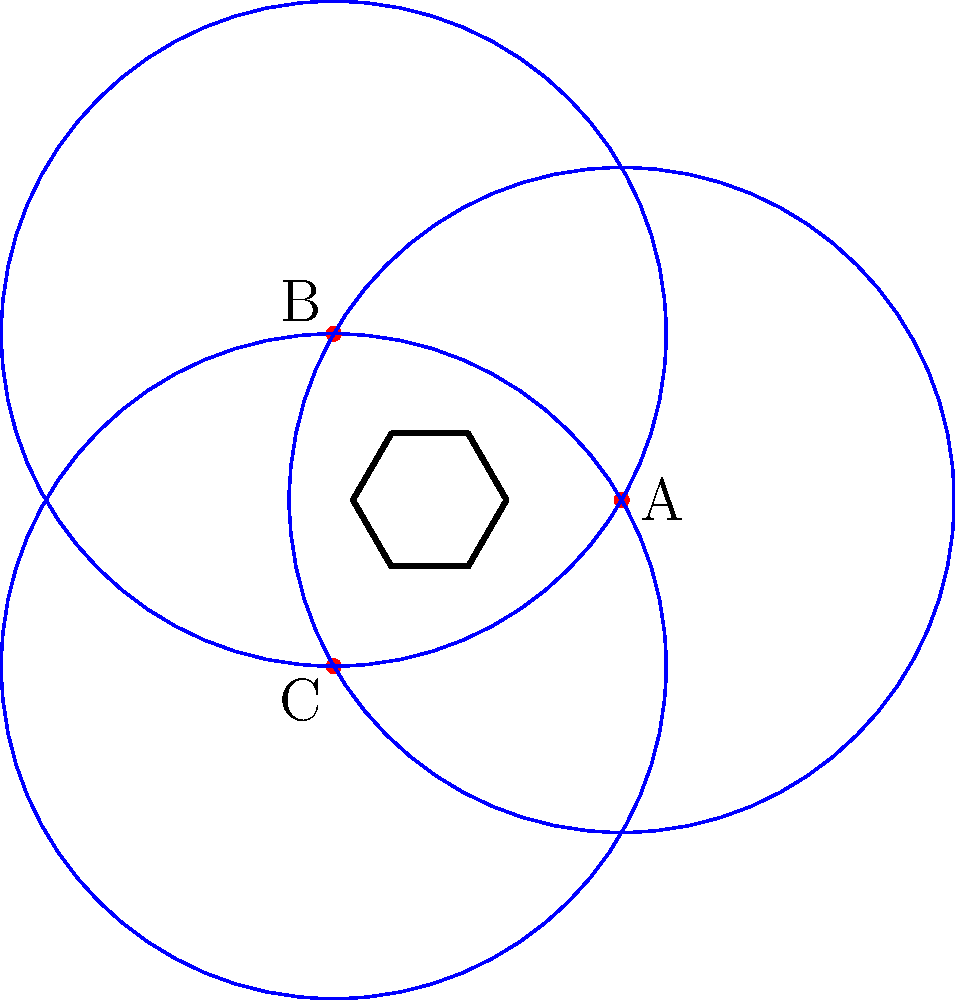In a hexagonal room with a side length of 5 meters, three Wi-Fi routers (A, B, and C) are placed as shown in the diagram. Each router has a coverage radius of 4.33 meters. What is the minimum number of additional routers needed to ensure complete coverage of the room? To solve this problem, we'll follow these steps:

1. Calculate the area of the hexagonal room:
   Area of a regular hexagon = $\frac{3\sqrt{3}}{2}s^2$, where s is the side length
   Area = $\frac{3\sqrt{3}}{2} * 5^2 = 64.95$ m²

2. Calculate the area covered by each router:
   Area of a circle = $\pi r^2$, where r is the radius
   Area covered by each router = $\pi * 4.33^2 = 58.88$ m²

3. Calculate the total area covered by the three routers:
   Total covered area = $3 * 58.88 = 176.64$ m²

4. However, there is significant overlap between the router coverages, so we need to estimate the actual covered area. Based on the diagram, we can approximate that about 70% of the total coverage area is effective:
   Effective covered area ≈ $176.64 * 0.7 = 123.65$ m²

5. Calculate the remaining area to be covered:
   Remaining area = Room area - Effective covered area
   Remaining area = $64.95 - 123.65 = -58.7$ m²

6. Since the remaining area is negative, it means the entire room is already covered by the three routers.

Therefore, no additional routers are needed to ensure complete coverage of the room.
Answer: 0 